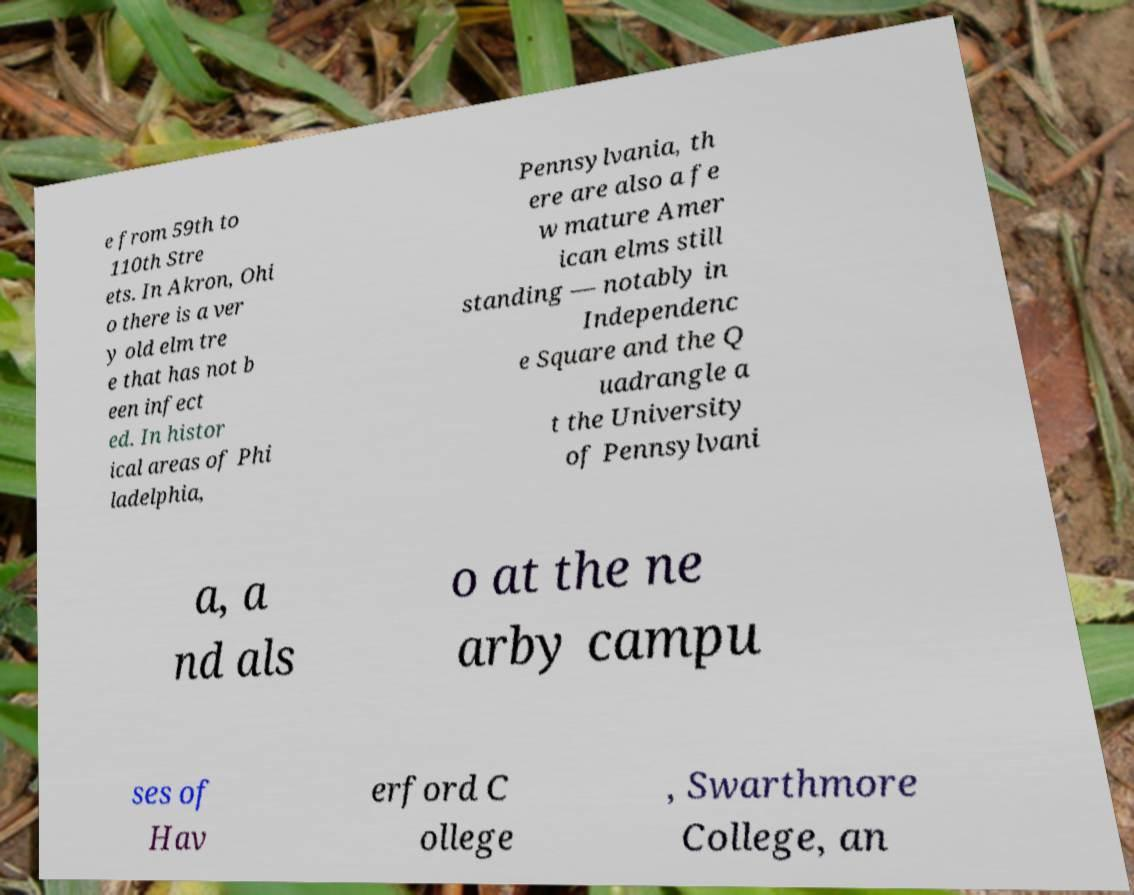I need the written content from this picture converted into text. Can you do that? e from 59th to 110th Stre ets. In Akron, Ohi o there is a ver y old elm tre e that has not b een infect ed. In histor ical areas of Phi ladelphia, Pennsylvania, th ere are also a fe w mature Amer ican elms still standing — notably in Independenc e Square and the Q uadrangle a t the University of Pennsylvani a, a nd als o at the ne arby campu ses of Hav erford C ollege , Swarthmore College, an 